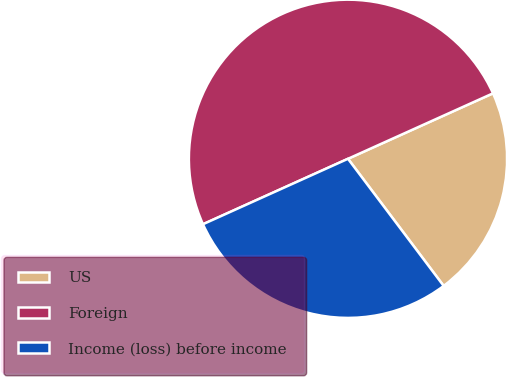Convert chart. <chart><loc_0><loc_0><loc_500><loc_500><pie_chart><fcel>US<fcel>Foreign<fcel>Income (loss) before income<nl><fcel>21.48%<fcel>50.0%<fcel>28.52%<nl></chart> 